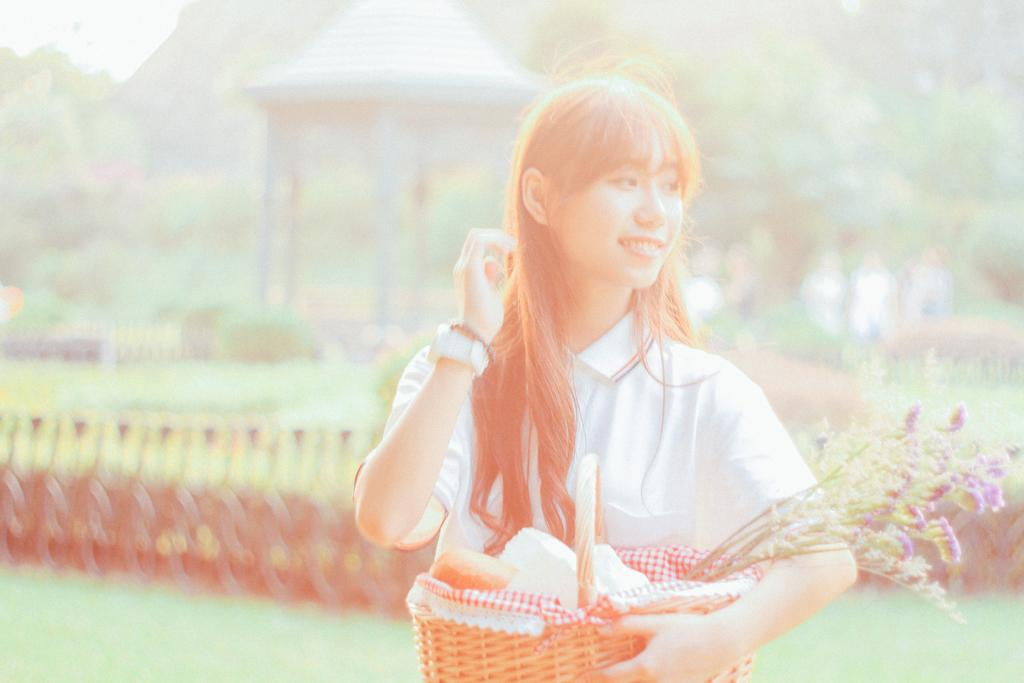Who is present in the image? There is a woman in the image. What is the woman wearing? The woman is wearing a white dress. What is the woman holding in the image? The woman is holding a basket. What can be seen in the background of the image? There is grass and trees in the background of the image. What type of weather can be seen in the image? The image does not provide information about the weather, as it only shows a woman in a white dress holding a basket with grass and trees in the background. 